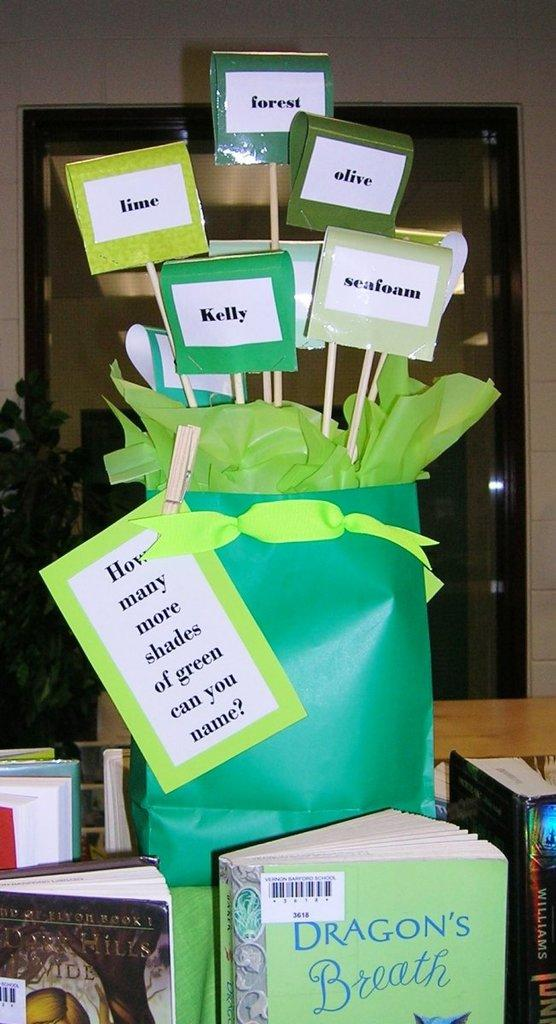<image>
Render a clear and concise summary of the photo. A green bag on a book display table. It says "how many shades of green can you name" and there's a signs with shades like lime, seafoam, kelly and olive. 